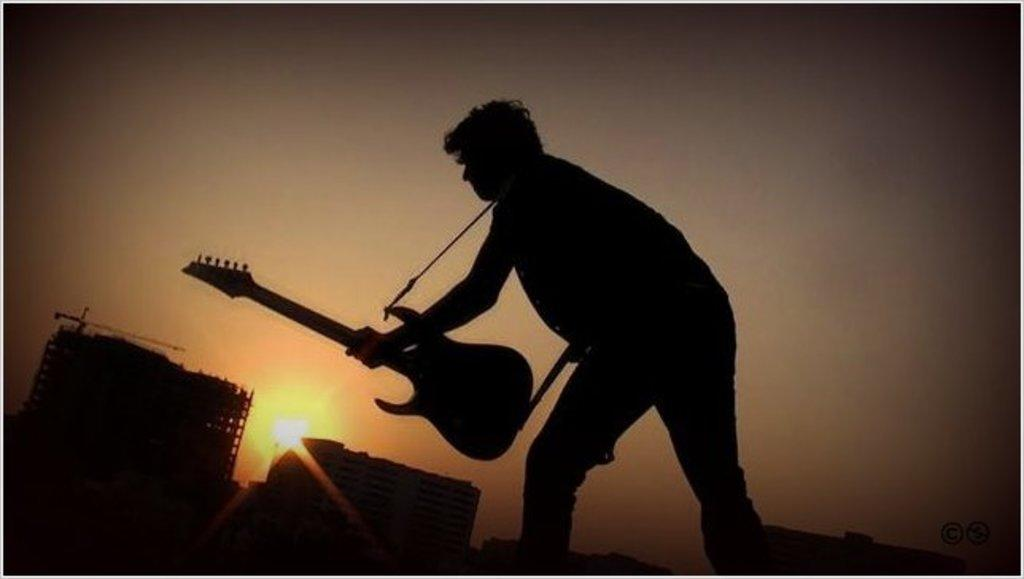Who is present in the image? There is a man in the image. What is the man holding in the image? The man is holding a guitar. What can be seen providing illumination in the image? There is a light in the image. What is visible in the background of the image? The sky is visible in the image. What type of powder is being used by the man in the image? There is no powder present in the image; the man is holding a guitar. Can you see a hose in the image? No, there is no hose present in the image. 